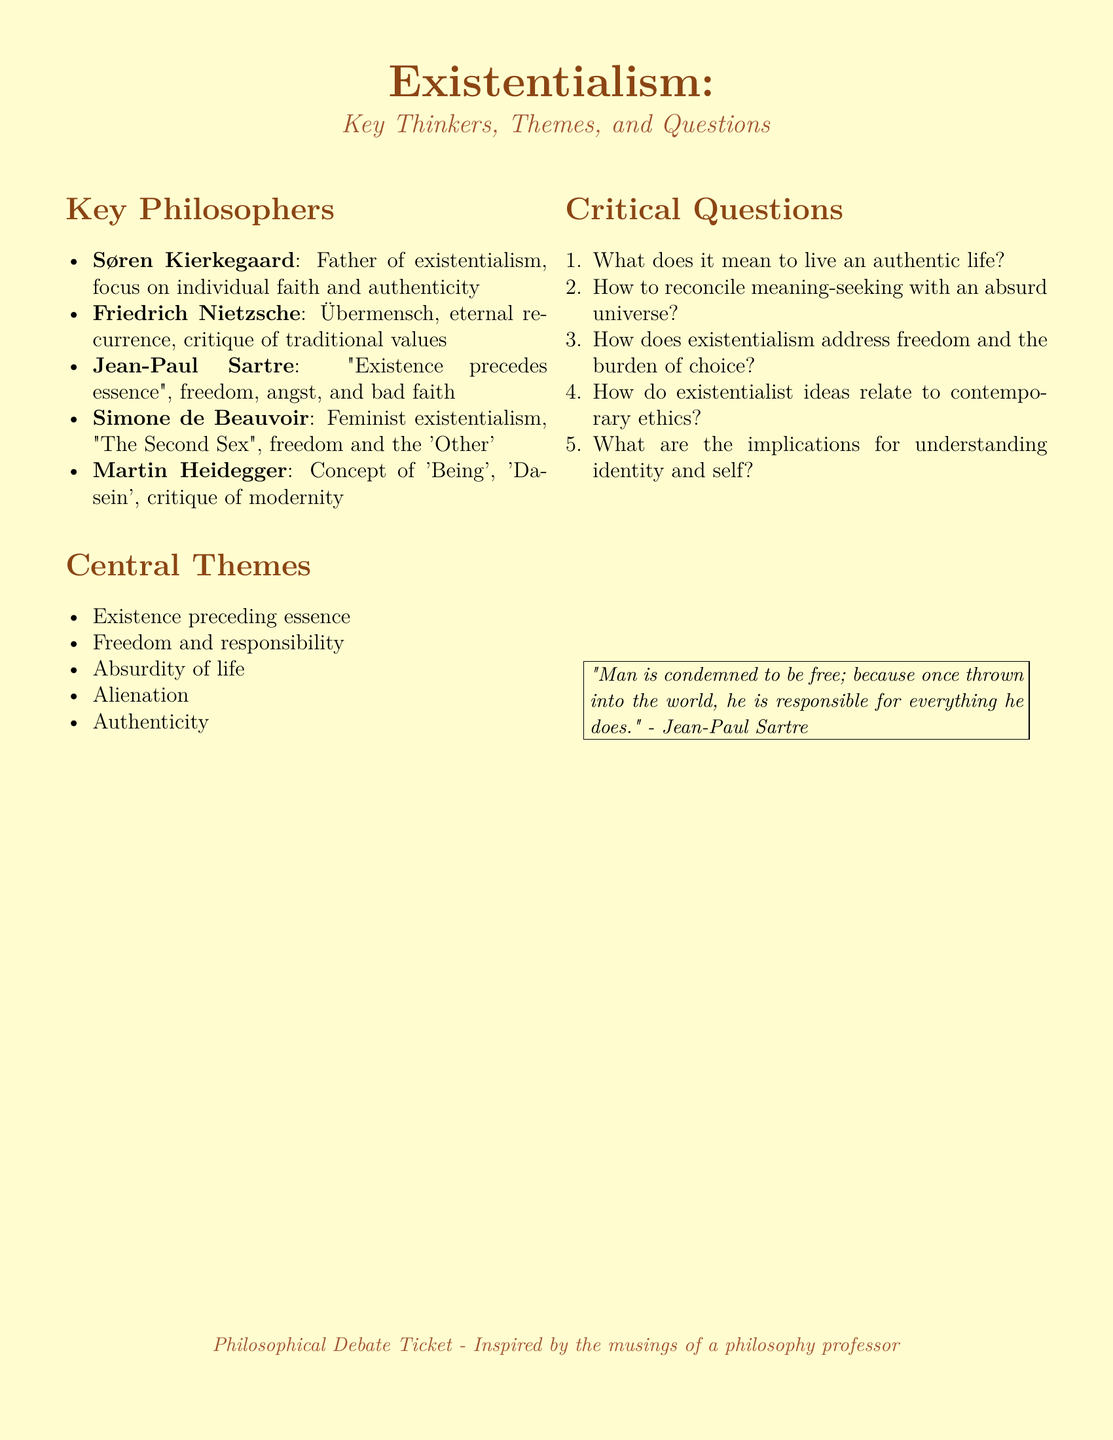What is the title of the document? The title is prominently displayed at the top of the document, announcing the topic discussed.
Answer: Existentialism Who is considered the father of existentialism? This is stated explicitly under the section about key philosophers, referring to a specific thinker.
Answer: Søren Kierkegaard What theme addresses the idea that existence comes before essence? This theme is listed among the central themes of existentialism, specifically pointing to a fundamental existentialist principle.
Answer: Existence preceding essence What philosopher critiqued traditional values? This philosopher is noted for his controversial views on traditional morality and the concept of the Übermensch in the document.
Answer: Friedrich Nietzsche Which philosopher is associated with feminist existentialism? The document's key philosophers section highlights this thinker's contributions specifically focused on gender and ethics.
Answer: Simone de Beauvoir How does existentialism relate to contemporary ethics? This question appears under critical questions, signaling complexity in the application of existentialism in modern contexts.
Answer: How do existentialist ideas relate to contemporary ethics? What does Jean-Paul Sartre claim about freedom? This quotation encapsulates Sartre's view of freedom and its responsibilities, illustrating a key existentialist ideology.
Answer: "Man is condemned to be free" What is the focus of existentialist thought regarding authenticity? This theme summarizes a crucial aspect of existentialism related to individual identity and true self-expression.
Answer: Authenticity What term describes the feeling of disconnection from the world? The document lists this as one of the central themes, which impacts existentialist thought and human experience.
Answer: Alienation 